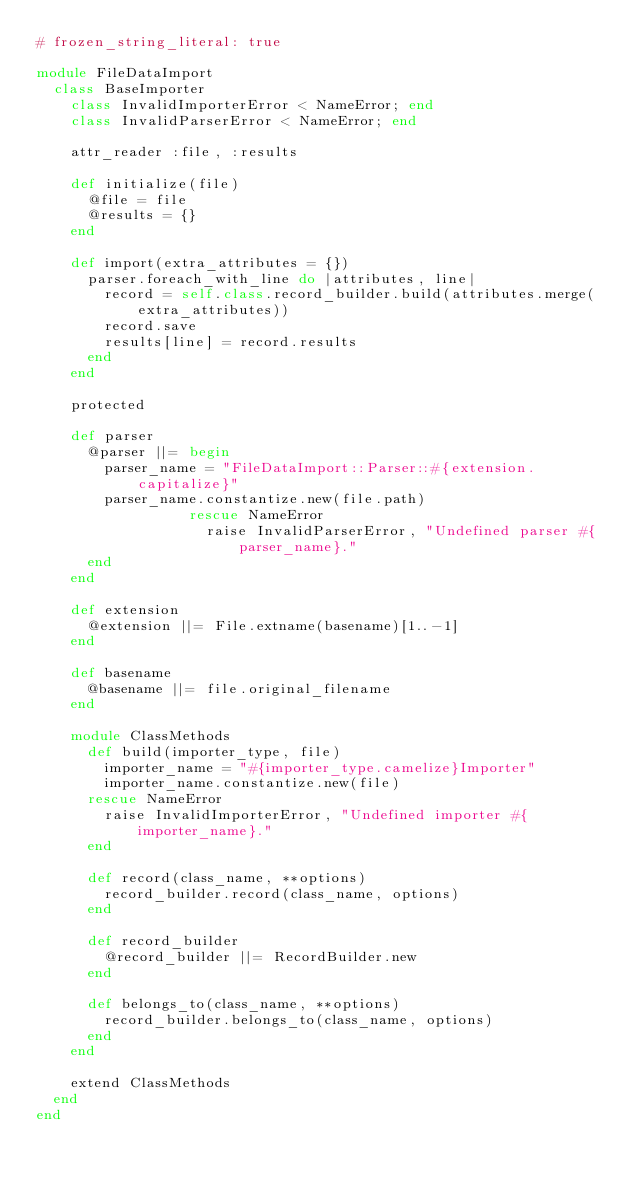Convert code to text. <code><loc_0><loc_0><loc_500><loc_500><_Ruby_># frozen_string_literal: true

module FileDataImport
  class BaseImporter
    class InvalidImporterError < NameError; end
    class InvalidParserError < NameError; end

    attr_reader :file, :results

    def initialize(file)
      @file = file
      @results = {}
    end

    def import(extra_attributes = {})
      parser.foreach_with_line do |attributes, line|
        record = self.class.record_builder.build(attributes.merge(extra_attributes))
        record.save
        results[line] = record.results
      end
    end

    protected

    def parser
      @parser ||= begin
        parser_name = "FileDataImport::Parser::#{extension.capitalize}"
        parser_name.constantize.new(file.path)
                  rescue NameError
                    raise InvalidParserError, "Undefined parser #{parser_name}."
      end
    end

    def extension
      @extension ||= File.extname(basename)[1..-1]
    end

    def basename
      @basename ||= file.original_filename
    end

    module ClassMethods
      def build(importer_type, file)
        importer_name = "#{importer_type.camelize}Importer"
        importer_name.constantize.new(file)
      rescue NameError
        raise InvalidImporterError, "Undefined importer #{importer_name}."
      end

      def record(class_name, **options)
        record_builder.record(class_name, options)
      end

      def record_builder
        @record_builder ||= RecordBuilder.new
      end

      def belongs_to(class_name, **options)
        record_builder.belongs_to(class_name, options)
      end
    end

    extend ClassMethods
  end
end
</code> 